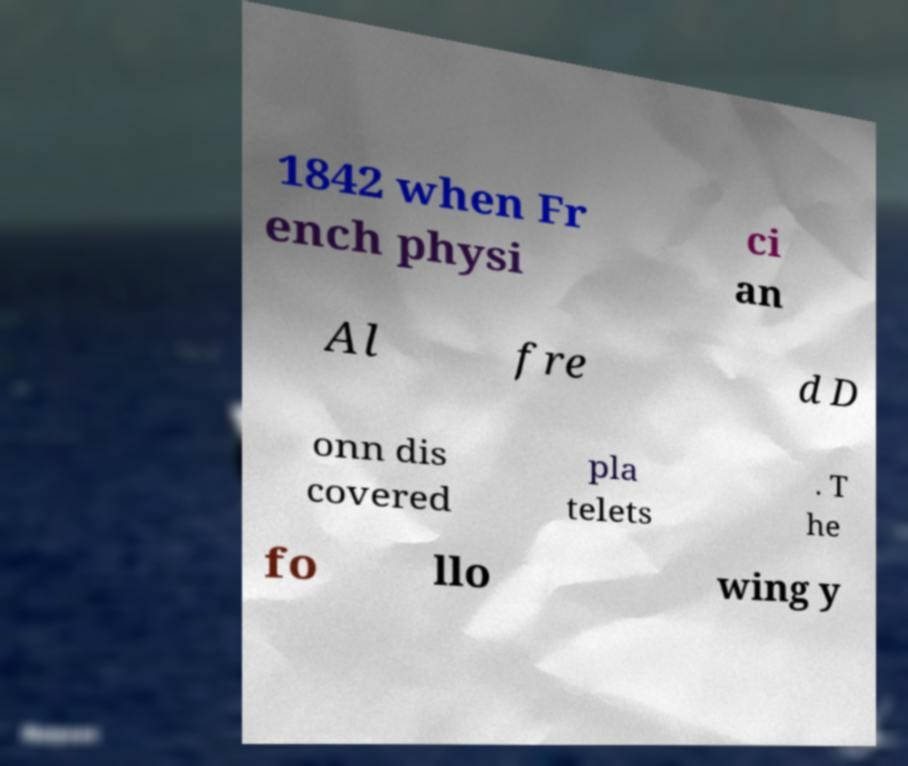Could you assist in decoding the text presented in this image and type it out clearly? 1842 when Fr ench physi ci an Al fre d D onn dis covered pla telets . T he fo llo wing y 